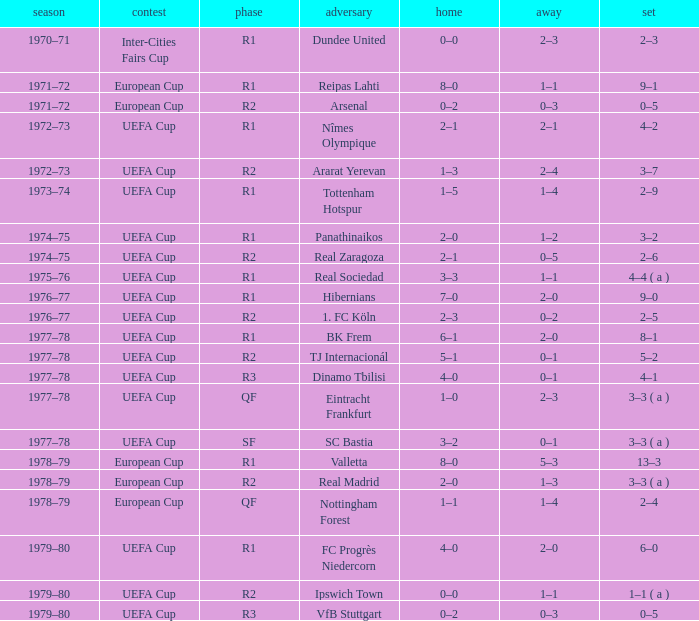At which phase is there a uefa cup competition and a 5-2 series? R2. 